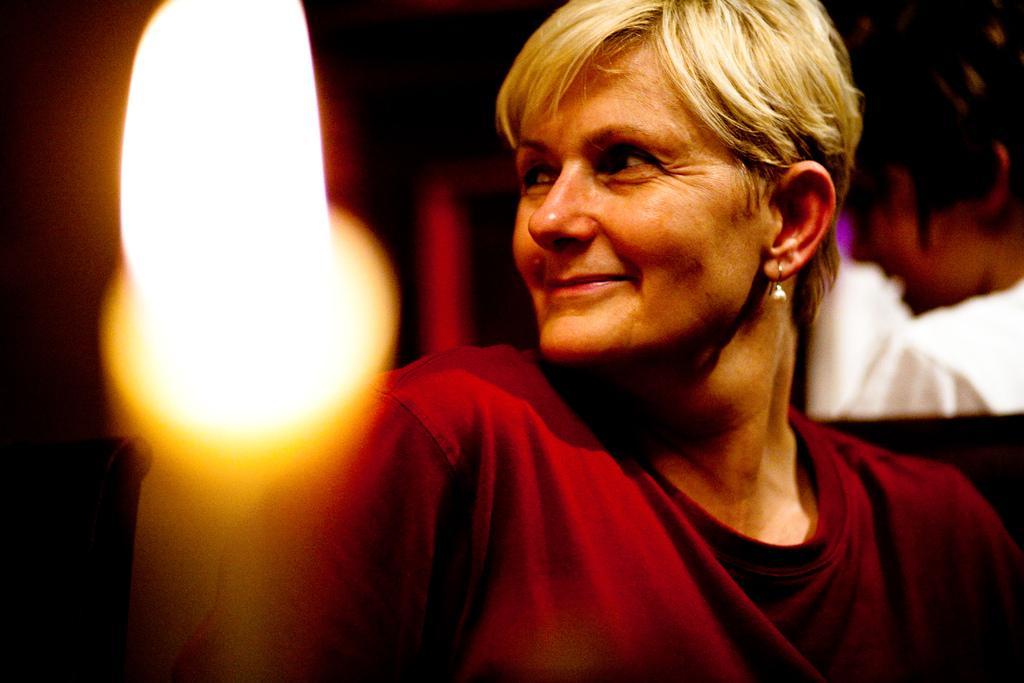Could you give a brief overview of what you see in this image? In the image we can see the close up image of the woman on the right side of the image, she is wearing clothes, earrings and she is smiling. Behind her there is another person wearing clothes. Here we can see the flame and the background is dark. 